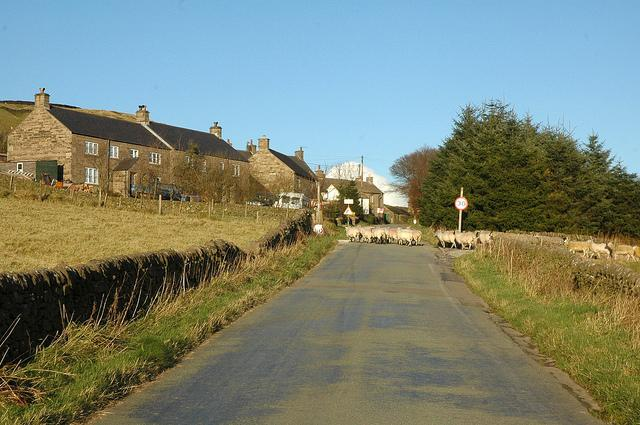When travelling this road for safety what should you allow to cross first?

Choices:
A) crickets
B) cars
C) sheep
D) flies sheep 